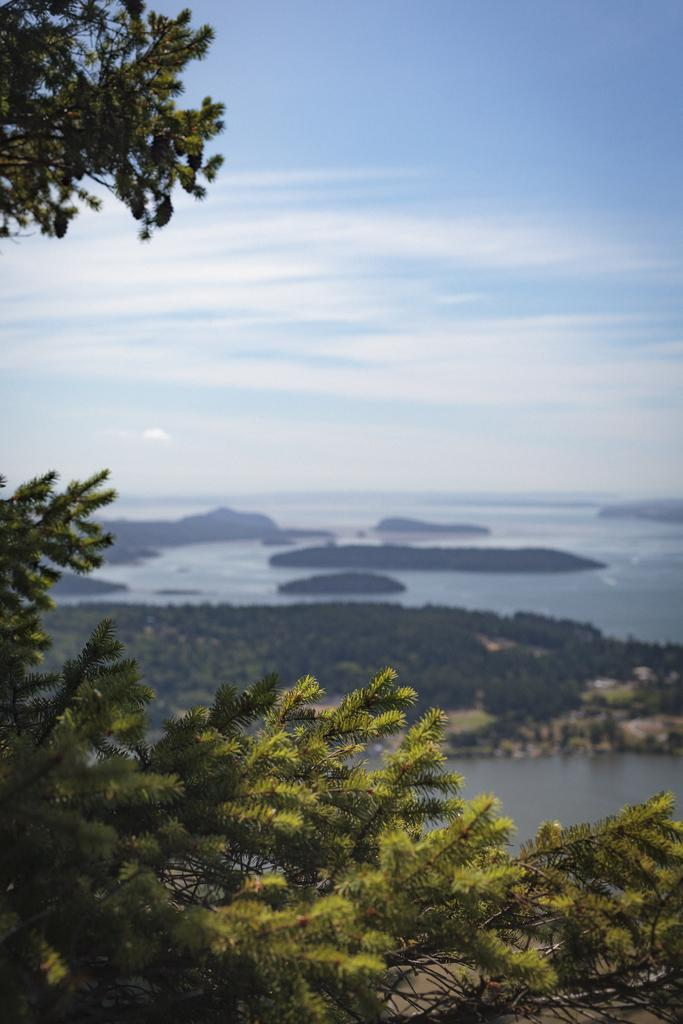What type of vegetation can be seen in the image? There are trees in the image. What natural element is visible in the image besides the trees? There is water visible in the image. What can be seen in the background of the image? The sky is visible in the background of the image. What is present in the sky? Clouds are present in the sky. What type of jewel is hanging from the tree in the image? There is no jewel hanging from the tree in the image; only trees, water, and the sky are present. 